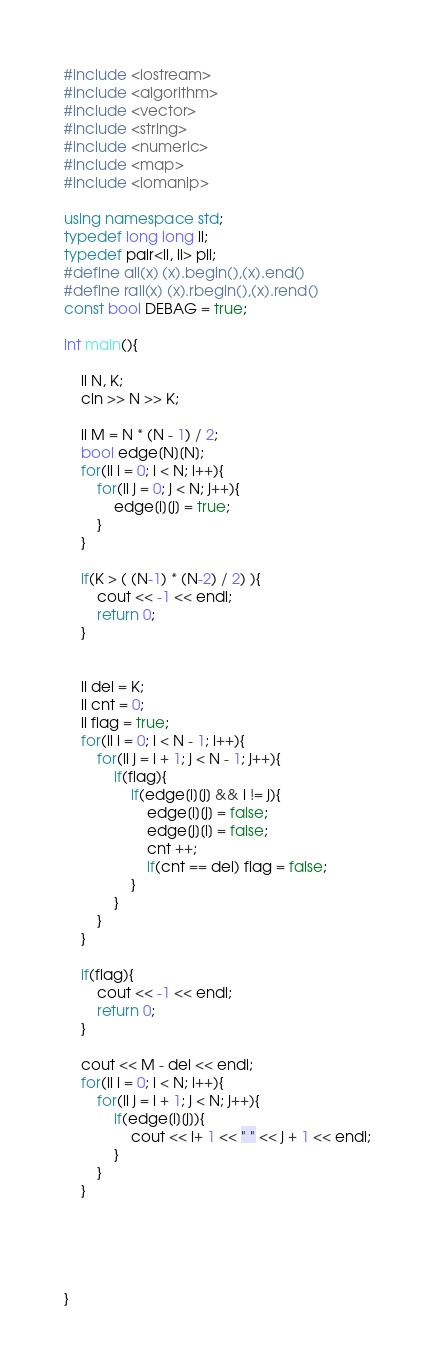<code> <loc_0><loc_0><loc_500><loc_500><_C++_>#include <iostream>
#include <algorithm>
#include <vector>
#include <string>
#include <numeric>
#include <map>
#include <iomanip>

using namespace std;    
typedef long long ll;
typedef pair<ll, ll> pll;
#define all(x) (x).begin(),(x).end()
#define rall(x) (x).rbegin(),(x).rend()
const bool DEBAG = true;

int main(){

    ll N, K;
    cin >> N >> K;

    ll M = N * (N - 1) / 2;
    bool edge[N][N];
    for(ll i = 0; i < N; i++){
        for(ll j = 0; j < N; j++){
            edge[i][j] = true;
        }
    }

    if(K > ( (N-1) * (N-2) / 2) ){
        cout << -1 << endl;
        return 0;
    }


    ll del = K;
    ll cnt = 0;
    ll flag = true;
    for(ll i = 0; i < N - 1; i++){
        for(ll j = i + 1; j < N - 1; j++){
            if(flag){
                if(edge[i][j] && i != j){
                    edge[i][j] = false;
                    edge[j][i] = false;
                    cnt ++;
                    if(cnt == del) flag = false;
                }
            }
        }
    }

    if(flag){
        cout << -1 << endl;
        return 0;
    }

    cout << M - del << endl;
    for(ll i = 0; i < N; i++){
        for(ll j = i + 1; j < N; j++){
            if(edge[i][j]){
                cout << i+ 1 << " " << j + 1 << endl;
            }
        }
    }





}</code> 